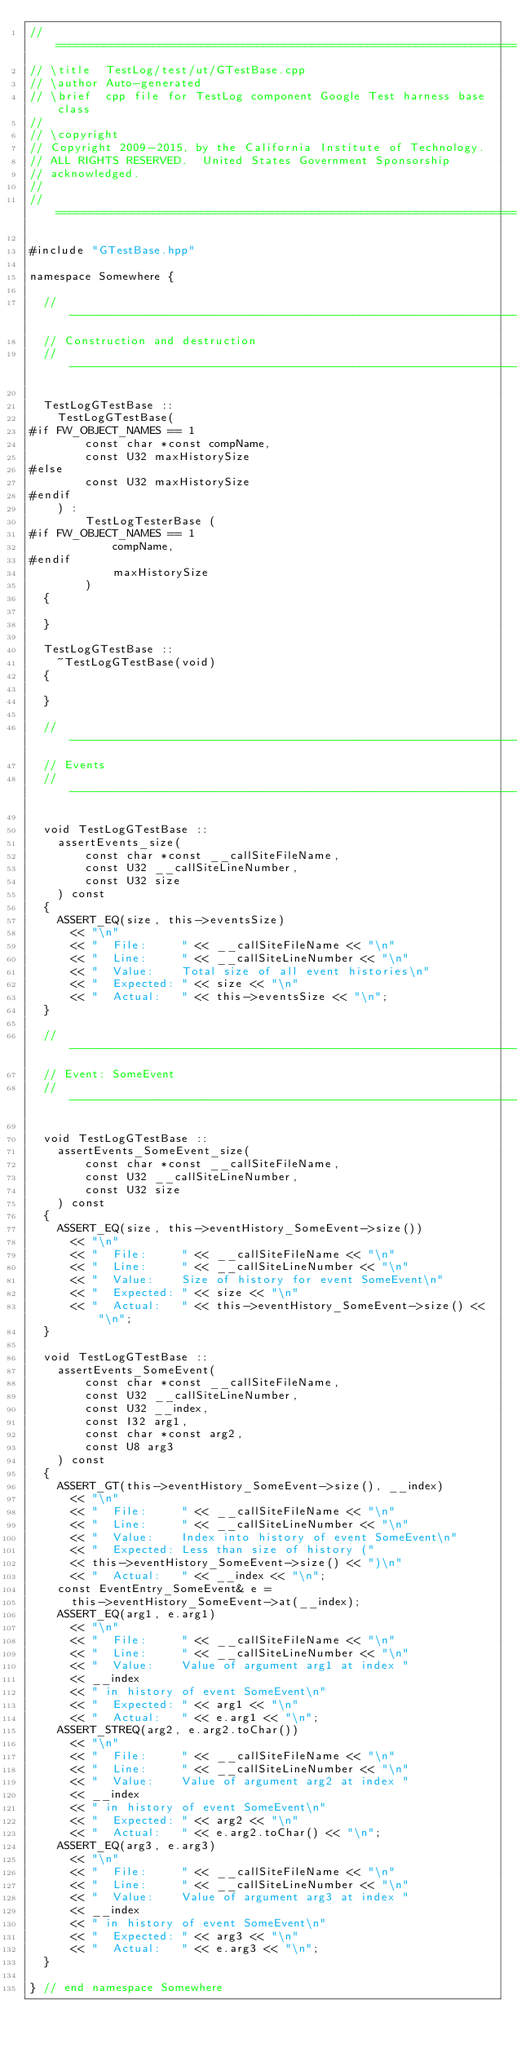Convert code to text. <code><loc_0><loc_0><loc_500><loc_500><_C++_>// ======================================================================
// \title  TestLog/test/ut/GTestBase.cpp
// \author Auto-generated
// \brief  cpp file for TestLog component Google Test harness base class
//
// \copyright
// Copyright 2009-2015, by the California Institute of Technology.
// ALL RIGHTS RESERVED.  United States Government Sponsorship
// acknowledged.
//
// ======================================================================

#include "GTestBase.hpp"

namespace Somewhere {

  // ----------------------------------------------------------------------
  // Construction and destruction
  // ----------------------------------------------------------------------

  TestLogGTestBase ::
    TestLogGTestBase(
#if FW_OBJECT_NAMES == 1
        const char *const compName,
        const U32 maxHistorySize
#else
        const U32 maxHistorySize
#endif
    ) : 
        TestLogTesterBase (
#if FW_OBJECT_NAMES == 1
            compName,
#endif
            maxHistorySize
        )
  {

  }

  TestLogGTestBase ::
    ~TestLogGTestBase(void)
  {

  }

  // ----------------------------------------------------------------------
  // Events
  // ----------------------------------------------------------------------

  void TestLogGTestBase ::
    assertEvents_size(
        const char *const __callSiteFileName,
        const U32 __callSiteLineNumber,
        const U32 size
    ) const
  {
    ASSERT_EQ(size, this->eventsSize)
      << "\n"
      << "  File:     " << __callSiteFileName << "\n"
      << "  Line:     " << __callSiteLineNumber << "\n"
      << "  Value:    Total size of all event histories\n"
      << "  Expected: " << size << "\n"
      << "  Actual:   " << this->eventsSize << "\n";
  }

  // ----------------------------------------------------------------------
  // Event: SomeEvent
  // ----------------------------------------------------------------------

  void TestLogGTestBase ::
    assertEvents_SomeEvent_size(
        const char *const __callSiteFileName,
        const U32 __callSiteLineNumber,
        const U32 size
    ) const
  {
    ASSERT_EQ(size, this->eventHistory_SomeEvent->size())
      << "\n"
      << "  File:     " << __callSiteFileName << "\n"
      << "  Line:     " << __callSiteLineNumber << "\n"
      << "  Value:    Size of history for event SomeEvent\n"
      << "  Expected: " << size << "\n"
      << "  Actual:   " << this->eventHistory_SomeEvent->size() << "\n";
  }

  void TestLogGTestBase ::
    assertEvents_SomeEvent(
        const char *const __callSiteFileName,
        const U32 __callSiteLineNumber,
        const U32 __index,
        const I32 arg1,
        const char *const arg2,
        const U8 arg3
    ) const
  {
    ASSERT_GT(this->eventHistory_SomeEvent->size(), __index)
      << "\n"
      << "  File:     " << __callSiteFileName << "\n"
      << "  Line:     " << __callSiteLineNumber << "\n"
      << "  Value:    Index into history of event SomeEvent\n"
      << "  Expected: Less than size of history (" 
      << this->eventHistory_SomeEvent->size() << ")\n"
      << "  Actual:   " << __index << "\n";
    const EventEntry_SomeEvent& e =
      this->eventHistory_SomeEvent->at(__index);
    ASSERT_EQ(arg1, e.arg1)
      << "\n"
      << "  File:     " << __callSiteFileName << "\n"
      << "  Line:     " << __callSiteLineNumber << "\n"
      << "  Value:    Value of argument arg1 at index "
      << __index
      << " in history of event SomeEvent\n"
      << "  Expected: " << arg1 << "\n"
      << "  Actual:   " << e.arg1 << "\n";
    ASSERT_STREQ(arg2, e.arg2.toChar())
      << "\n"
      << "  File:     " << __callSiteFileName << "\n"
      << "  Line:     " << __callSiteLineNumber << "\n"
      << "  Value:    Value of argument arg2 at index "
      << __index
      << " in history of event SomeEvent\n"
      << "  Expected: " << arg2 << "\n"
      << "  Actual:   " << e.arg2.toChar() << "\n";
    ASSERT_EQ(arg3, e.arg3)
      << "\n"
      << "  File:     " << __callSiteFileName << "\n"
      << "  Line:     " << __callSiteLineNumber << "\n"
      << "  Value:    Value of argument arg3 at index "
      << __index
      << " in history of event SomeEvent\n"
      << "  Expected: " << arg3 << "\n"
      << "  Actual:   " << e.arg3 << "\n";
  }

} // end namespace Somewhere
</code> 